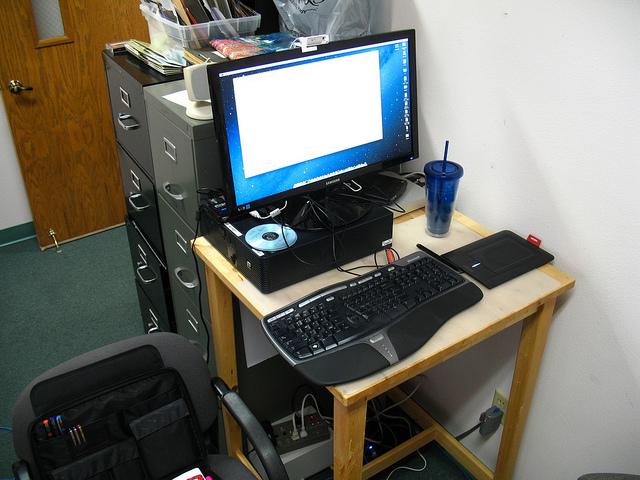What kind of keyboard is this?
Write a very short answer. Computer keyboard. Is there a computer here?
Concise answer only. Yes. What OS does this computer have?
Concise answer only. Windows. 